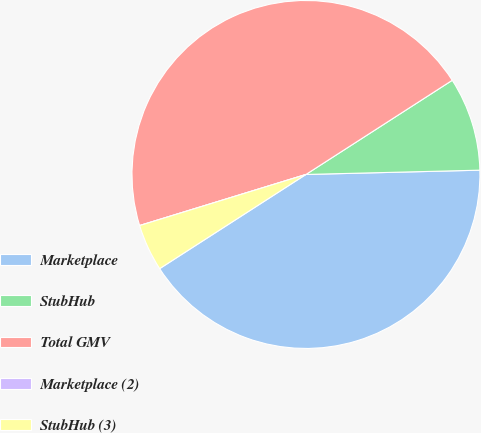Convert chart. <chart><loc_0><loc_0><loc_500><loc_500><pie_chart><fcel>Marketplace<fcel>StubHub<fcel>Total GMV<fcel>Marketplace (2)<fcel>StubHub (3)<nl><fcel>41.29%<fcel>8.71%<fcel>45.64%<fcel>0.0%<fcel>4.36%<nl></chart> 